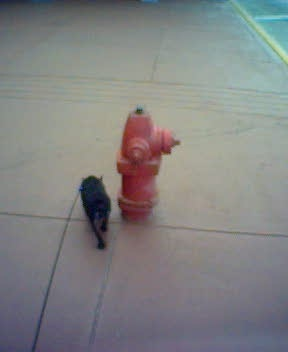Describe the objects in this image and their specific colors. I can see fire hydrant in navy, maroon, and brown tones and dog in navy, black, gray, and darkgray tones in this image. 